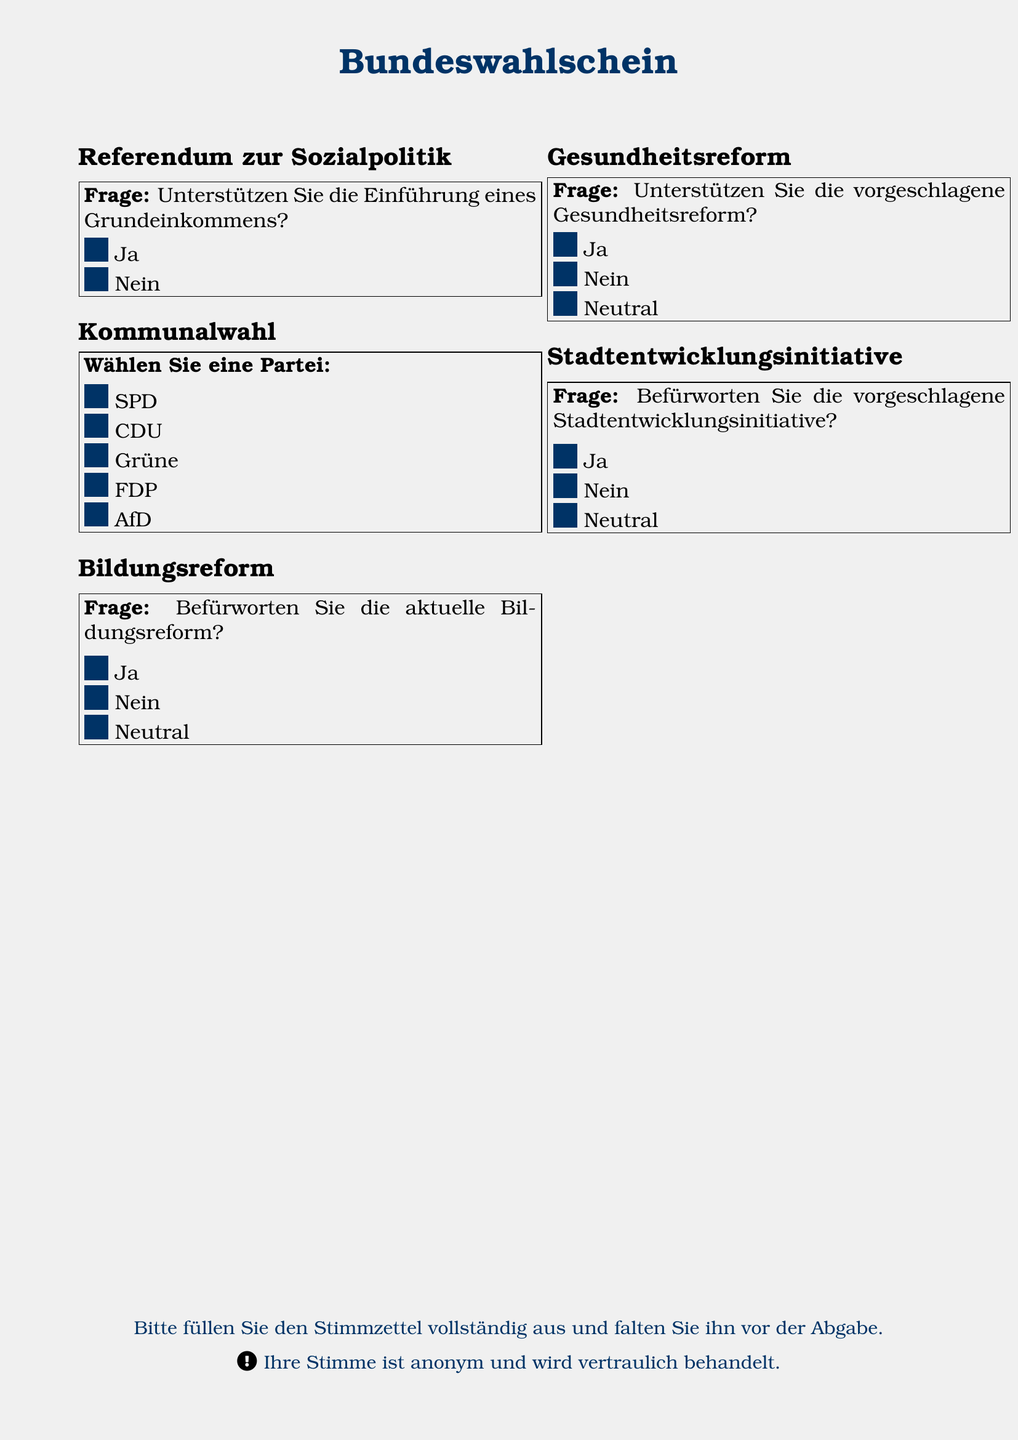What is the main question of the social policy referendum? The main question asks if the respondent supports the introduction of a basic income.
Answer: Einführung eines Grundeinkommens How many parties are listed for the local election? There are five parties listed for selection in the local election.
Answer: 5 What option is included in the question about the educational reform? The question allows respondents to choose whether they are in favor of the current educational reform based on three options.
Answer: Ja, Nein, Neutral What question is asked regarding urban development? The question asks if respondents support the proposed urban development initiative.
Answer: Befürworten Sie die vorgeschlagene Stadtentwicklungsinitiative? Which party option is available on the ballot first? The first party option listed is the SPD.
Answer: SPD What choice is included in the health reform question? The survey question on health reform provides options to support, oppose, or remain neutral.
Answer: Ja, Nein, Neutral What color is used for visual elements in the ballot? The document uses a shade of blue, defined as ballot blue, for its visual elements.
Answer: ballotblue How is voter anonymity addressed in the ballot? The ballot states that the vote is confidential and treated anonymously.
Answer: anonym und vertraulich What is the document type? The document is a voting ballot designed for various referendums and elections.
Answer: Bundeswahlschein 